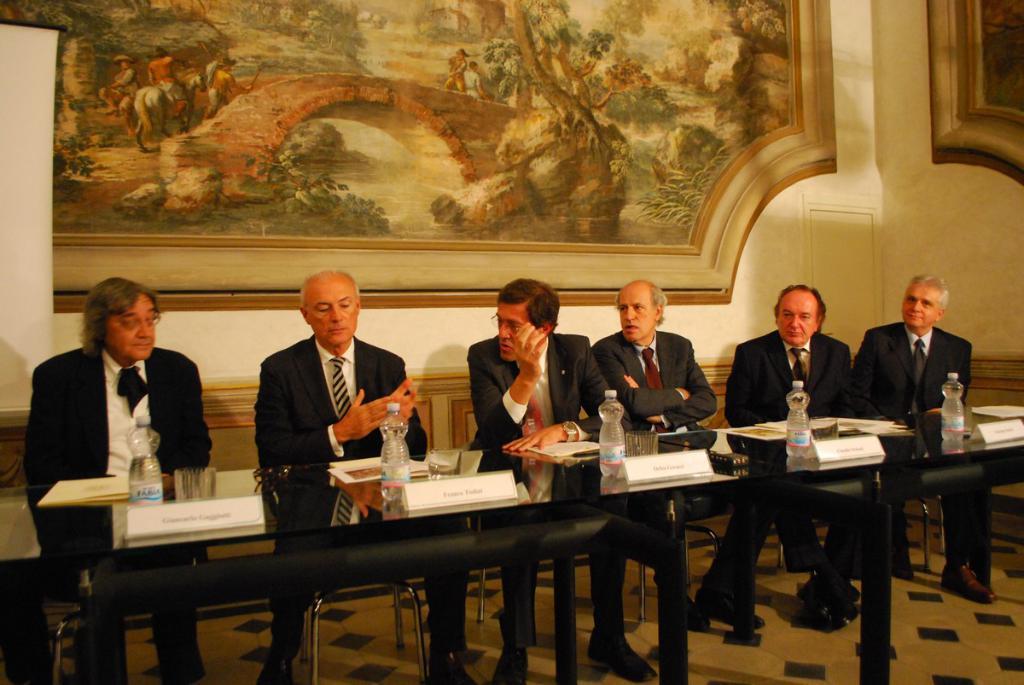Please provide a concise description of this image. In this image there are group of persons who are wearing suits sitting on the chairs at the foreground of the image there are bottles,glasses on top of the table and at the background of the image there is a painting attached to the wall. 